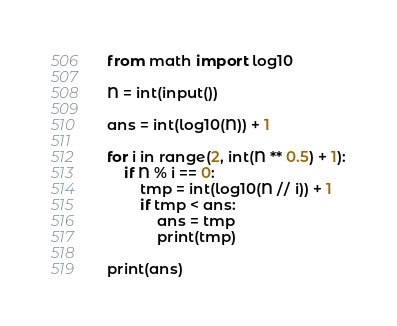Convert code to text. <code><loc_0><loc_0><loc_500><loc_500><_Python_>from math import log10

N = int(input())

ans = int(log10(N)) + 1

for i in range(2, int(N ** 0.5) + 1):
    if N % i == 0:
        tmp = int(log10(N // i)) + 1
        if tmp < ans:
            ans = tmp
            print(tmp)

print(ans)</code> 